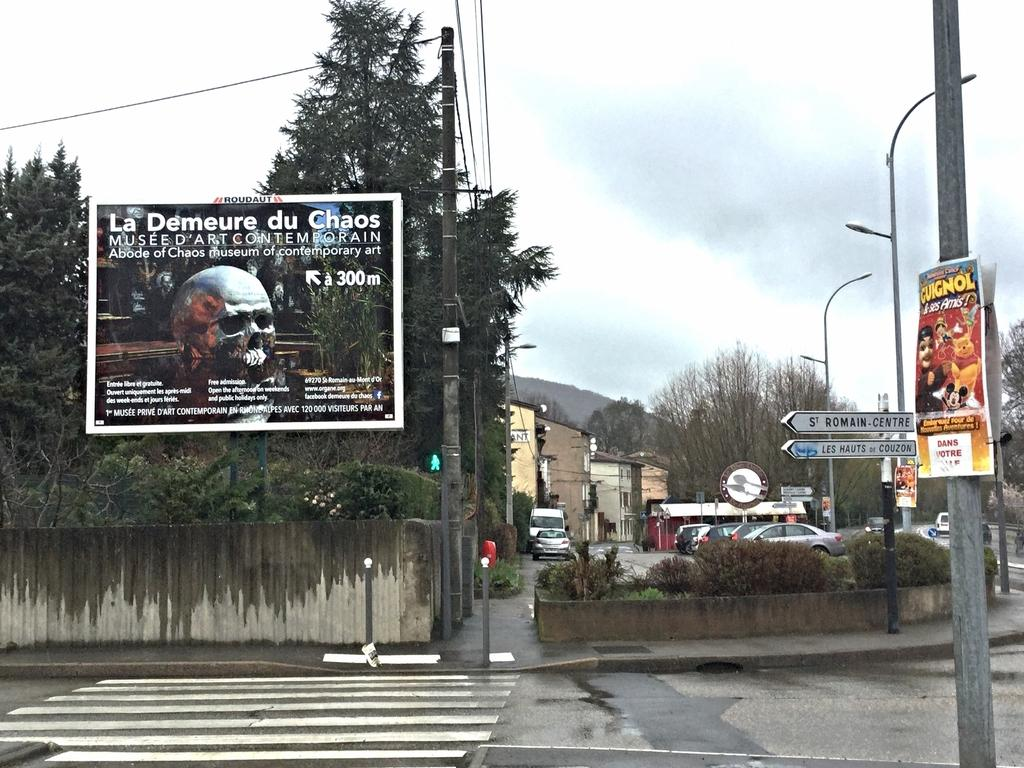What type of structures can be seen in the image? There are houses in the image. What else is visible besides the houses? There are vehicles, poles with lights, boards, trees, and a banner in the image. Can you describe the poles with lights? The poles with lights are likely streetlights or decorative lights. What type of vegetation is present in the image? There are trees in the image. What time does the actor appear on stage in the image? There is no actor or stage present in the image; it features houses, vehicles, poles with lights, boards, trees, and a banner. 